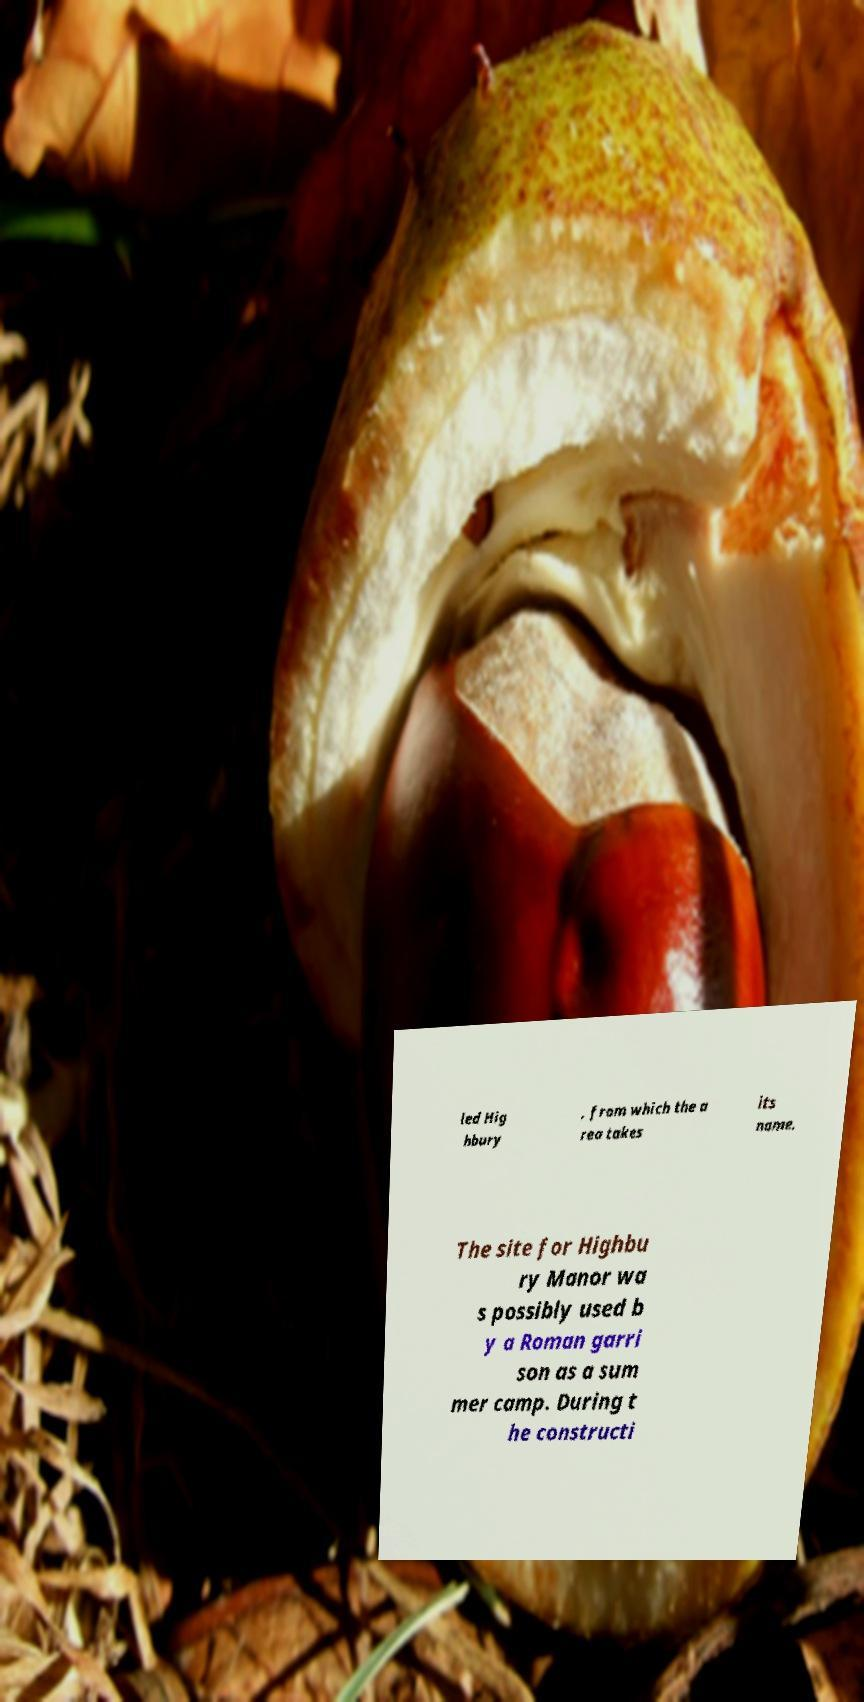I need the written content from this picture converted into text. Can you do that? led Hig hbury , from which the a rea takes its name. The site for Highbu ry Manor wa s possibly used b y a Roman garri son as a sum mer camp. During t he constructi 